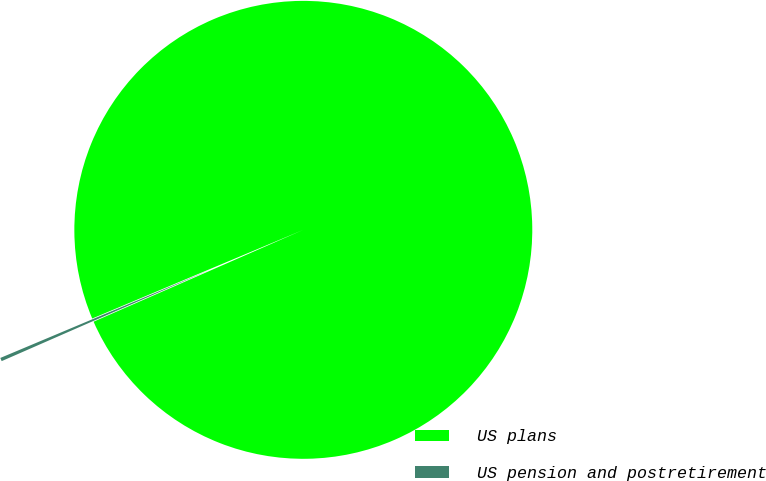Convert chart to OTSL. <chart><loc_0><loc_0><loc_500><loc_500><pie_chart><fcel>US plans<fcel>US pension and postretirement<nl><fcel>99.76%<fcel>0.24%<nl></chart> 